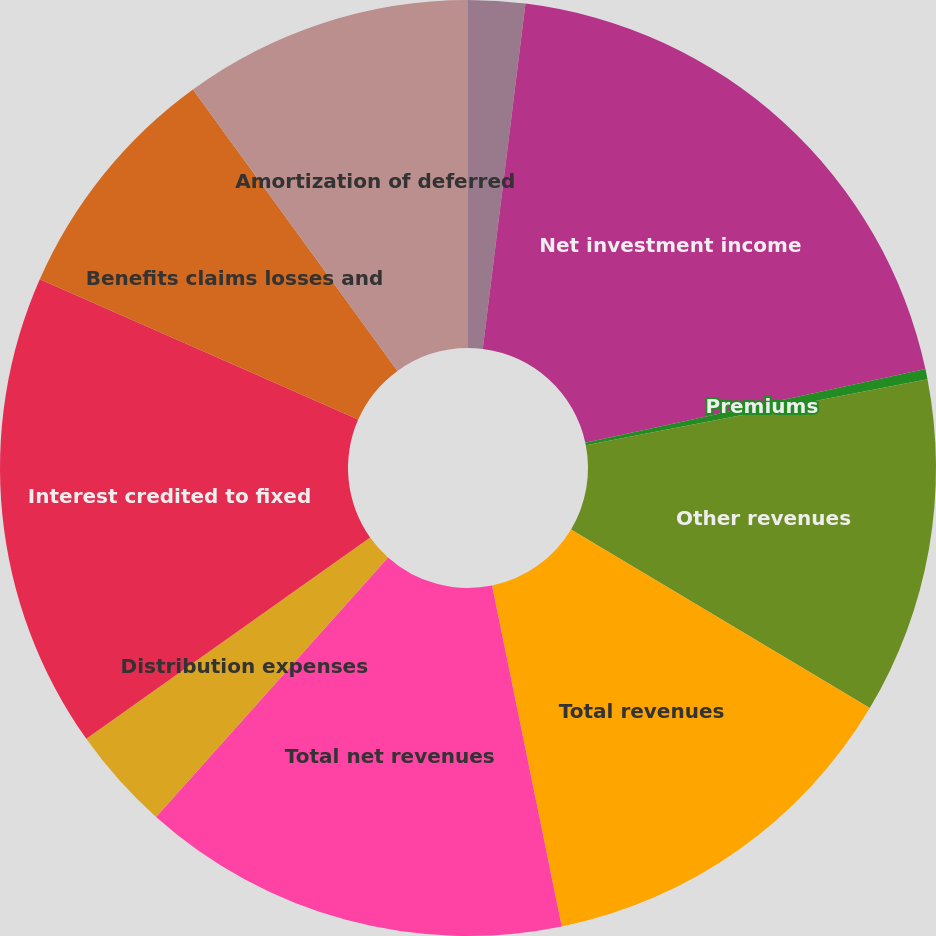Convert chart. <chart><loc_0><loc_0><loc_500><loc_500><pie_chart><fcel>Distribution fees<fcel>Net investment income<fcel>Premiums<fcel>Other revenues<fcel>Total revenues<fcel>Total net revenues<fcel>Distribution expenses<fcel>Interest credited to fixed<fcel>Benefits claims losses and<fcel>Amortization of deferred<nl><fcel>1.96%<fcel>19.65%<fcel>0.35%<fcel>11.61%<fcel>13.22%<fcel>14.82%<fcel>3.57%<fcel>16.43%<fcel>8.39%<fcel>10.0%<nl></chart> 